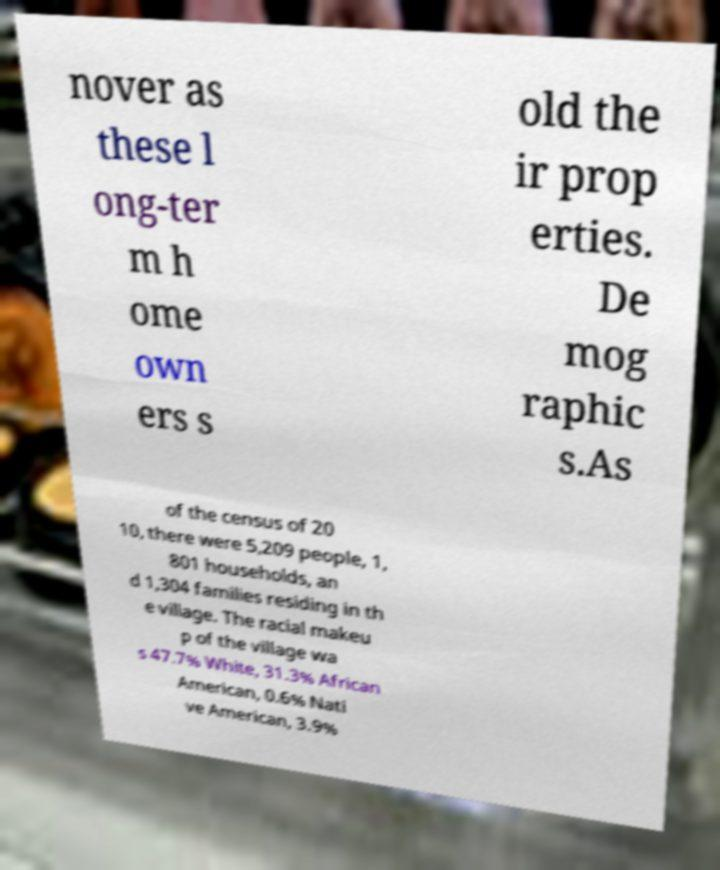Could you extract and type out the text from this image? nover as these l ong-ter m h ome own ers s old the ir prop erties. De mog raphic s.As of the census of 20 10, there were 5,209 people, 1, 801 households, an d 1,304 families residing in th e village. The racial makeu p of the village wa s 47.7% White, 31.3% African American, 0.6% Nati ve American, 3.9% 